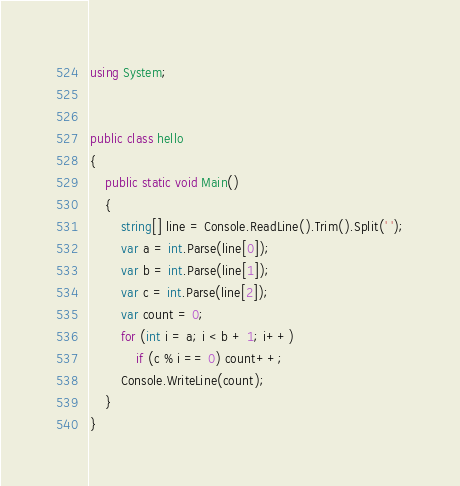<code> <loc_0><loc_0><loc_500><loc_500><_C#_>using System;


public class hello
{
    public static void Main()
    {
        string[] line = Console.ReadLine().Trim().Split(' ');
        var a = int.Parse(line[0]);
        var b = int.Parse(line[1]);
        var c = int.Parse(line[2]);
        var count = 0;
        for (int i = a; i < b + 1; i++)
            if (c % i == 0) count++;
        Console.WriteLine(count);
    }
}</code> 